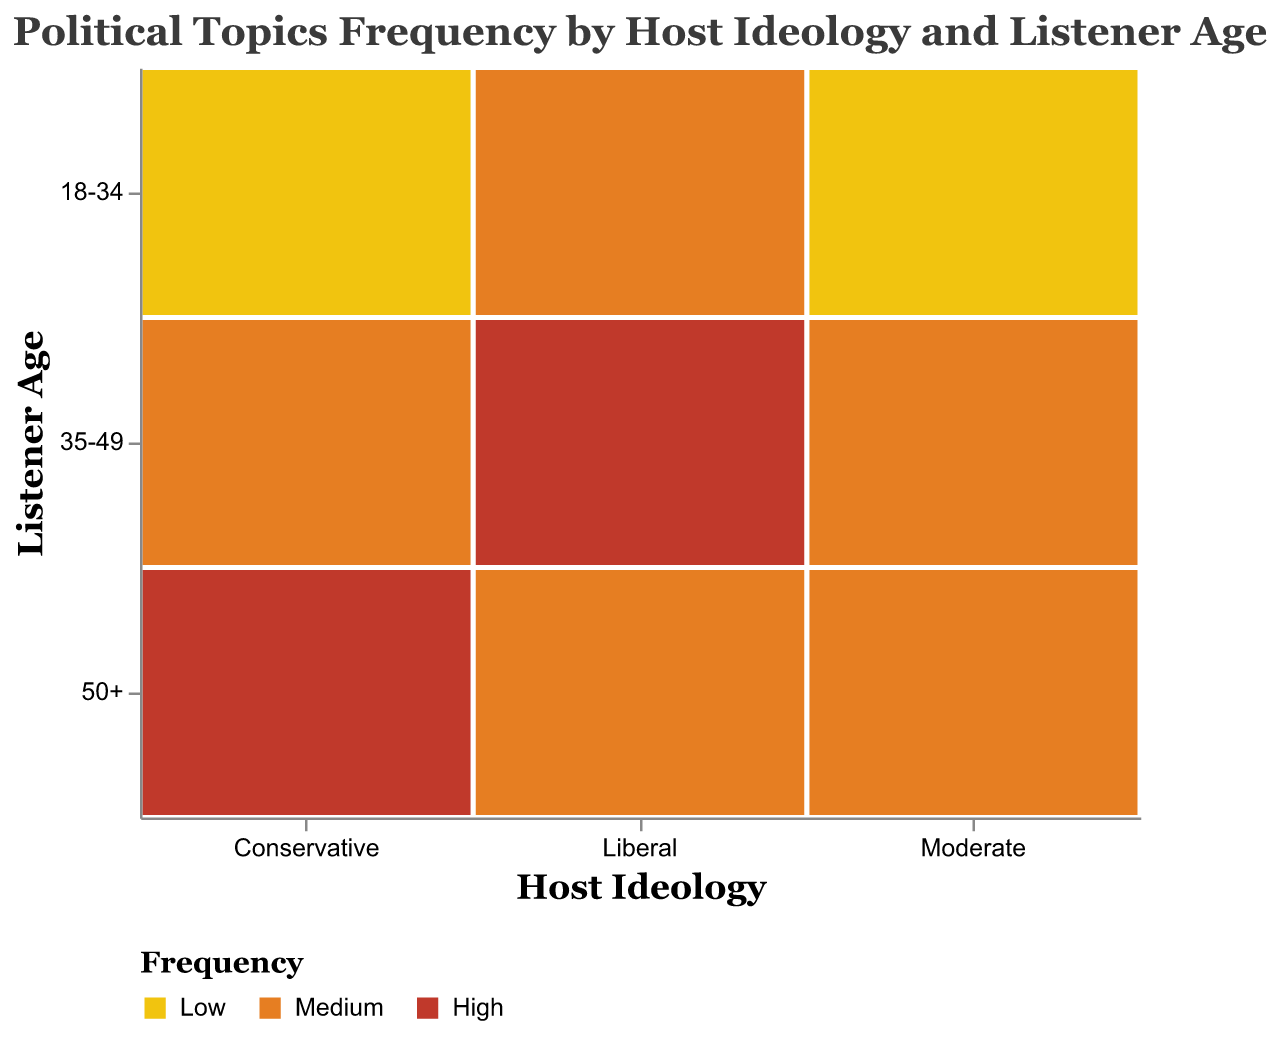How does the frequency of discussing political topics among Conservative hosts vary by listener age? For Conservative hosts, the frequency of discussing political topics is highest for listeners aged 50+, medium for listeners aged 35-49, and low for listeners aged 18-34. This can be seen from the color-coded mosaic plot sections under the Conservative category
Answer: High for 50+, medium for 35-49, low for 18-34 What is the title of the mosaic plot? The title of the mosaic plot is "Political Topics Frequency by Host Ideology and Listener Age," which is displayed at the top of the figure
Answer: Political Topics Frequency by Host Ideology and Listener Age Which listener age group has the highest frequency of political topics for Liberal hosts? For Liberal hosts, the highest frequency of political topics is for the listener age group 35-49. This can be identified by the darkest colored section under the Liberal category for the 35-49 age group
Answer: 35-49 Compare the frequency of political topics between Moderate and Conservative hosts for listeners aged 18-34. Moderate hosts have a low frequency in discussing political topics for the 18-34 age group, similar to the Conservative hosts for the same age group. Both have the same frequency
Answer: Equal (Low for both) Which host ideology has medium frequency of discussing political topics for the 50+ listener age group? The Conservative and Moderate hosts both discuss political topics with medium frequency for the 50+ listener age group
Answer: Conservative and Moderate How many listener age groups does the mosaic plot analyze for each host ideology? The mosaic plot analyzes three listener age groups for each host ideology: 50+, 35-49, and 18-34. These age groups can be seen on the vertical axis of the plot
Answer: Three Which listener age group has the lowest frequency of political topics for Moderate hosts, and how does it compare to other groups in the same category? For Moderate hosts, the 18-34 age group has the lowest frequency of political topics. Comparing to other groups in the same category, the other age groups (50+ and 35-49) have medium frequency
Answer: 18-34 (low), others medium How does the frequency of discussing political topics for listeners aged 35-49 compare across all host ideologies? For listeners aged 35-49, Conservative hosts discuss political topics with a medium frequency, Moderate hosts with a medium frequency, and Liberal hosts with a high frequency. This can be seen by comparing the colors across the 35-49 rows for each host ideology
Answer: Conservative and Moderate (Medium), Liberal (High) Are there any host ideologies where all listener age groups have the same frequency of political topics? No, there are no host ideologies where all listener age groups have the same frequency of political topics. Each host ideology has varying frequencies across different listener age groups
Answer: No 